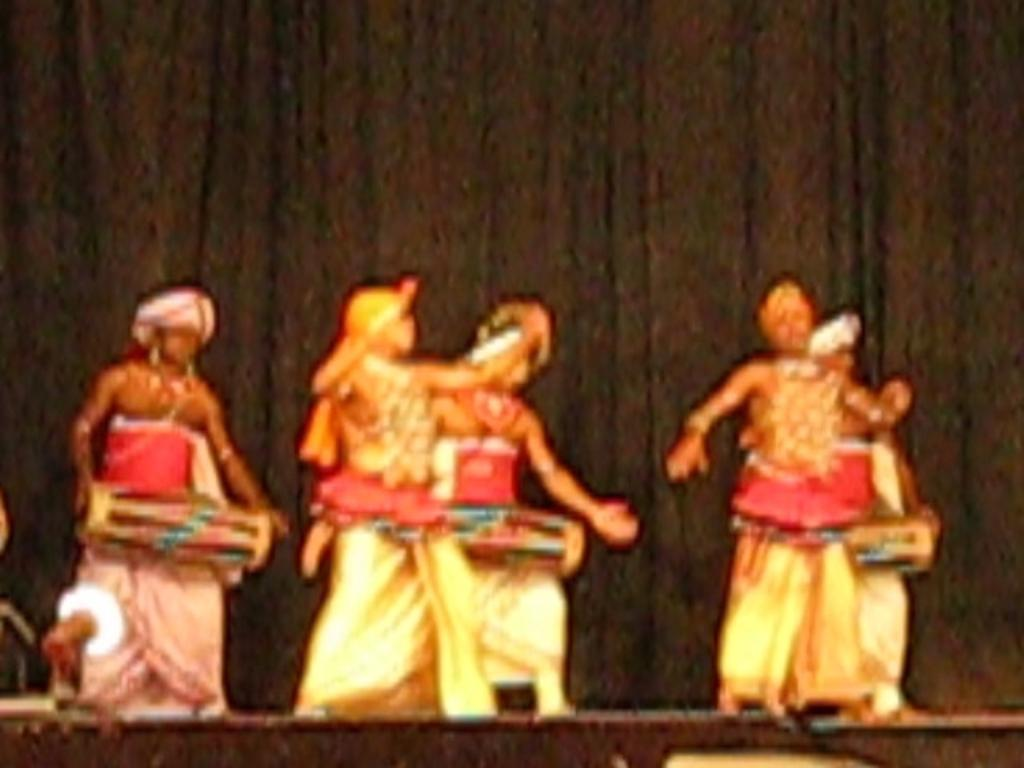Who is present in the image? There are people in the image. Where are the people located? The people are standing on a stage. What are the people doing on the stage? The people are playing musical instruments. What can be seen in the background of the image? There is a black curtain in the background of the image. What type of cherries are being offered to the audience in the image? There are no cherries present in the image; the people are playing musical instruments on a stage. 